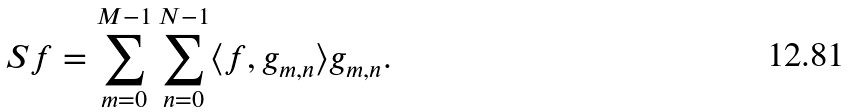Convert formula to latex. <formula><loc_0><loc_0><loc_500><loc_500>S f = \sum _ { m = 0 } ^ { M - 1 } \sum _ { n = 0 } ^ { N - 1 } \langle f , g _ { m , n } \rangle g _ { m , n } .</formula> 